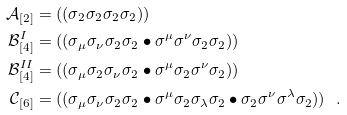Convert formula to latex. <formula><loc_0><loc_0><loc_500><loc_500>\mathcal { A } _ { [ 2 ] } & = ( ( \sigma _ { 2 } \sigma _ { 2 } \sigma _ { 2 } \sigma _ { 2 } ) ) \\ \mathcal { B } ^ { I } _ { [ 4 ] } & = ( ( \sigma _ { \mu } \sigma _ { \nu } \sigma _ { 2 } \sigma _ { 2 } \bullet \sigma ^ { \mu } \sigma ^ { \nu } \sigma _ { 2 } \sigma _ { 2 } ) ) \\ \mathcal { B } ^ { I I } _ { [ 4 ] } & = ( ( \sigma _ { \mu } \sigma _ { 2 } \sigma _ { \nu } \sigma _ { 2 } \bullet \sigma ^ { \mu } \sigma _ { 2 } \sigma ^ { \nu } \sigma _ { 2 } ) ) \\ \mathcal { C } _ { [ 6 ] } & = ( ( \sigma _ { \mu } \sigma _ { \nu } \sigma _ { 2 } \sigma _ { 2 } \bullet \sigma ^ { \mu } \sigma _ { 2 } \sigma _ { \lambda } \sigma _ { 2 } \bullet \sigma _ { 2 } \sigma ^ { \nu } \sigma ^ { \lambda } \sigma _ { 2 } ) ) \ \ .</formula> 